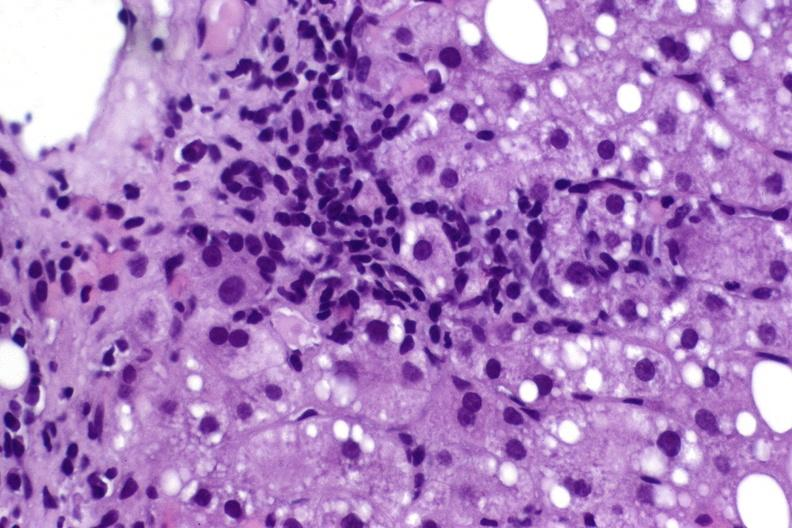s hepatobiliary present?
Answer the question using a single word or phrase. Yes 